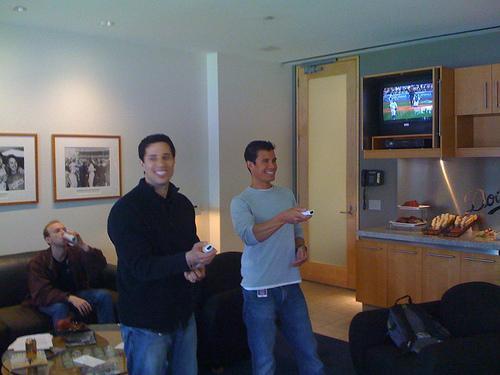How many people are on the couch?
Give a very brief answer. 1. How many couches are visible?
Give a very brief answer. 2. How many people can be seen?
Give a very brief answer. 3. How many backpacks are in the picture?
Give a very brief answer. 1. How many white cars are on the road?
Give a very brief answer. 0. 